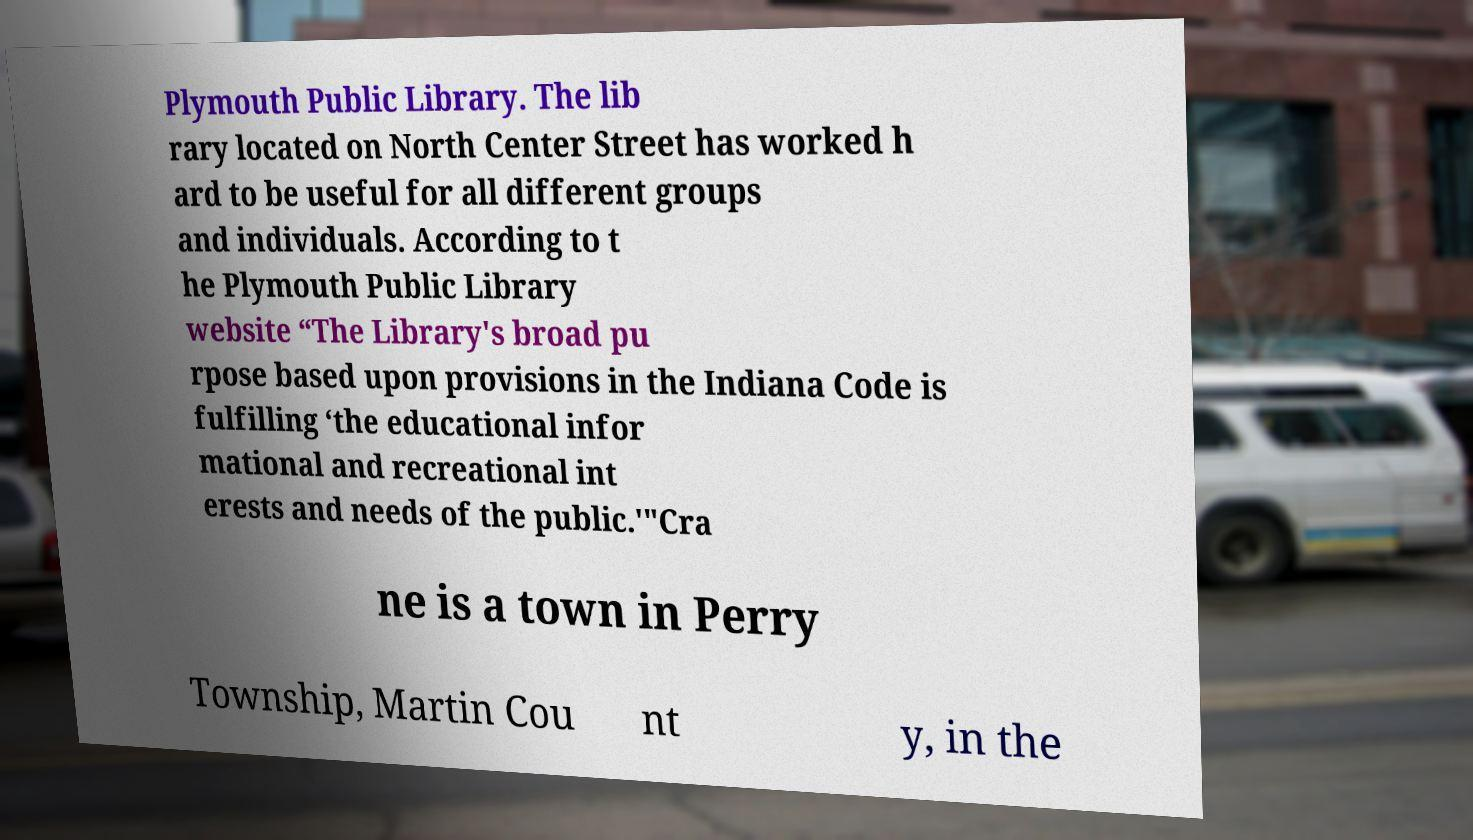Can you accurately transcribe the text from the provided image for me? Plymouth Public Library. The lib rary located on North Center Street has worked h ard to be useful for all different groups and individuals. According to t he Plymouth Public Library website “The Library's broad pu rpose based upon provisions in the Indiana Code is fulfilling ‘the educational infor mational and recreational int erests and needs of the public.'"Cra ne is a town in Perry Township, Martin Cou nt y, in the 